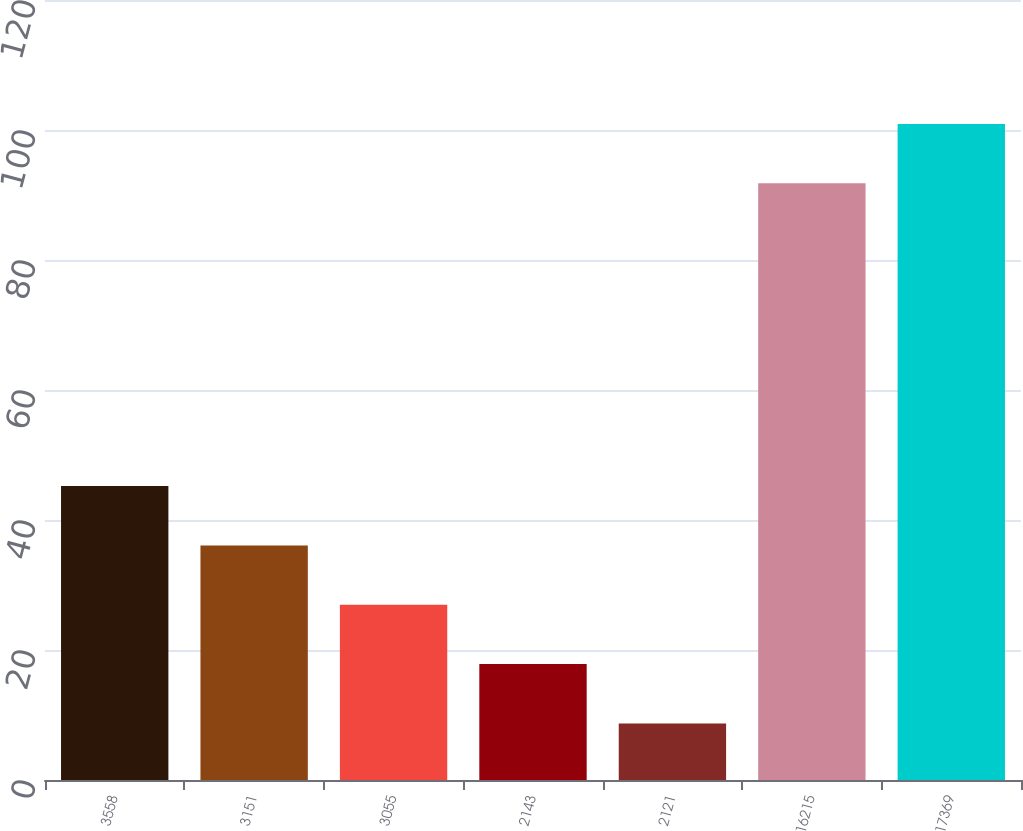Convert chart. <chart><loc_0><loc_0><loc_500><loc_500><bar_chart><fcel>3558<fcel>3151<fcel>3055<fcel>2143<fcel>2121<fcel>16215<fcel>17369<nl><fcel>45.22<fcel>36.09<fcel>26.96<fcel>17.83<fcel>8.7<fcel>91.8<fcel>100.93<nl></chart> 